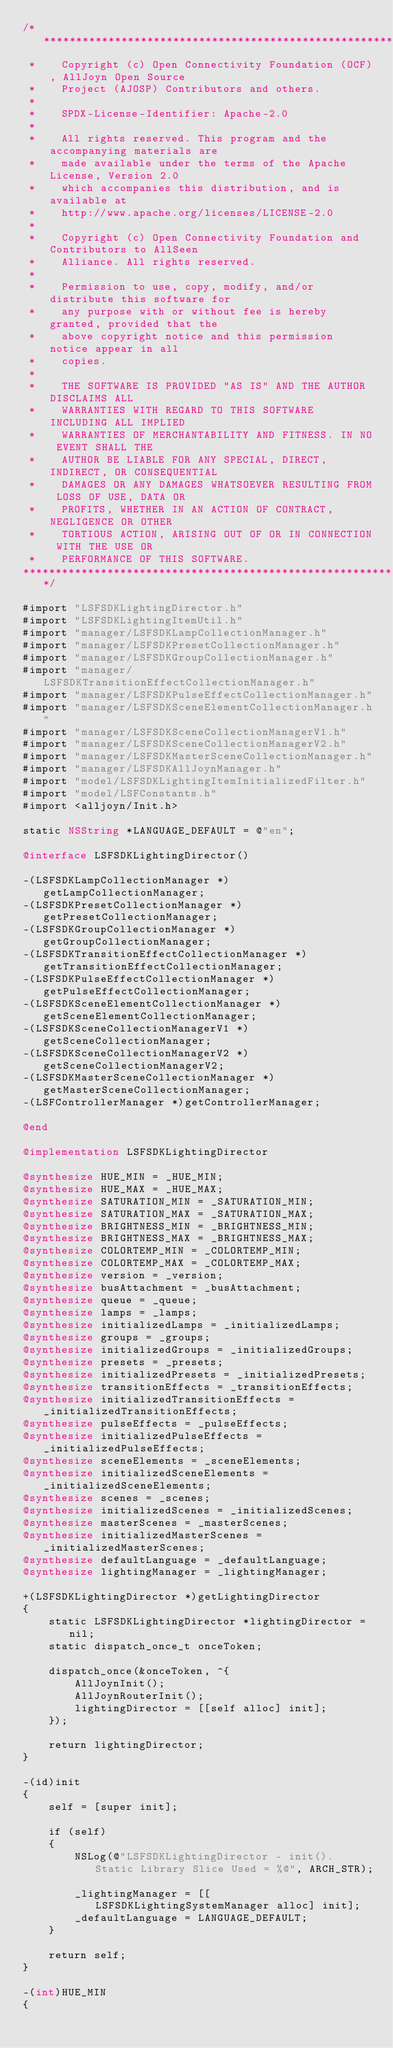Convert code to text. <code><loc_0><loc_0><loc_500><loc_500><_ObjectiveC_>/******************************************************************************
 *    Copyright (c) Open Connectivity Foundation (OCF), AllJoyn Open Source
 *    Project (AJOSP) Contributors and others.
 *    
 *    SPDX-License-Identifier: Apache-2.0
 *    
 *    All rights reserved. This program and the accompanying materials are
 *    made available under the terms of the Apache License, Version 2.0
 *    which accompanies this distribution, and is available at
 *    http://www.apache.org/licenses/LICENSE-2.0
 *    
 *    Copyright (c) Open Connectivity Foundation and Contributors to AllSeen
 *    Alliance. All rights reserved.
 *    
 *    Permission to use, copy, modify, and/or distribute this software for
 *    any purpose with or without fee is hereby granted, provided that the
 *    above copyright notice and this permission notice appear in all
 *    copies.
 *    
 *    THE SOFTWARE IS PROVIDED "AS IS" AND THE AUTHOR DISCLAIMS ALL
 *    WARRANTIES WITH REGARD TO THIS SOFTWARE INCLUDING ALL IMPLIED
 *    WARRANTIES OF MERCHANTABILITY AND FITNESS. IN NO EVENT SHALL THE
 *    AUTHOR BE LIABLE FOR ANY SPECIAL, DIRECT, INDIRECT, OR CONSEQUENTIAL
 *    DAMAGES OR ANY DAMAGES WHATSOEVER RESULTING FROM LOSS OF USE, DATA OR
 *    PROFITS, WHETHER IN AN ACTION OF CONTRACT, NEGLIGENCE OR OTHER
 *    TORTIOUS ACTION, ARISING OUT OF OR IN CONNECTION WITH THE USE OR
 *    PERFORMANCE OF THIS SOFTWARE.
******************************************************************************/

#import "LSFSDKLightingDirector.h"
#import "LSFSDKLightingItemUtil.h"
#import "manager/LSFSDKLampCollectionManager.h"
#import "manager/LSFSDKPresetCollectionManager.h"
#import "manager/LSFSDKGroupCollectionManager.h"
#import "manager/LSFSDKTransitionEffectCollectionManager.h"
#import "manager/LSFSDKPulseEffectCollectionManager.h"
#import "manager/LSFSDKSceneElementCollectionManager.h"
#import "manager/LSFSDKSceneCollectionManagerV1.h"
#import "manager/LSFSDKSceneCollectionManagerV2.h"
#import "manager/LSFSDKMasterSceneCollectionManager.h"
#import "manager/LSFSDKAllJoynManager.h"
#import "model/LSFSDKLightingItemInitializedFilter.h"
#import "model/LSFConstants.h"
#import <alljoyn/Init.h>

static NSString *LANGUAGE_DEFAULT = @"en";

@interface LSFSDKLightingDirector()

-(LSFSDKLampCollectionManager *)getLampCollectionManager;
-(LSFSDKPresetCollectionManager *)getPresetCollectionManager;
-(LSFSDKGroupCollectionManager *)getGroupCollectionManager;
-(LSFSDKTransitionEffectCollectionManager *)getTransitionEffectCollectionManager;
-(LSFSDKPulseEffectCollectionManager *)getPulseEffectCollectionManager;
-(LSFSDKSceneElementCollectionManager *)getSceneElementCollectionManager;
-(LSFSDKSceneCollectionManagerV1 *)getSceneCollectionManager;
-(LSFSDKSceneCollectionManagerV2 *)getSceneCollectionManagerV2;
-(LSFSDKMasterSceneCollectionManager *)getMasterSceneCollectionManager;
-(LSFControllerManager *)getControllerManager;

@end

@implementation LSFSDKLightingDirector

@synthesize HUE_MIN = _HUE_MIN;
@synthesize HUE_MAX = _HUE_MAX;
@synthesize SATURATION_MIN = _SATURATION_MIN;
@synthesize SATURATION_MAX = _SATURATION_MAX;
@synthesize BRIGHTNESS_MIN = _BRIGHTNESS_MIN;
@synthesize BRIGHTNESS_MAX = _BRIGHTNESS_MAX;
@synthesize COLORTEMP_MIN = _COLORTEMP_MIN;
@synthesize COLORTEMP_MAX = _COLORTEMP_MAX;
@synthesize version = _version;
@synthesize busAttachment = _busAttachment;
@synthesize queue = _queue;
@synthesize lamps = _lamps;
@synthesize initializedLamps = _initializedLamps;
@synthesize groups = _groups;
@synthesize initializedGroups = _initializedGroups;
@synthesize presets = _presets;
@synthesize initializedPresets = _initializedPresets;
@synthesize transitionEffects = _transitionEffects;
@synthesize initializedTransitionEffects = _initializedTransitionEffects;
@synthesize pulseEffects = _pulseEffects;
@synthesize initializedPulseEffects = _initializedPulseEffects;
@synthesize sceneElements = _sceneElements;
@synthesize initializedSceneElements = _initializedSceneElements;
@synthesize scenes = _scenes;
@synthesize initializedScenes = _initializedScenes;
@synthesize masterScenes = _masterScenes;
@synthesize initializedMasterScenes = _initializedMasterScenes;
@synthesize defaultLanguage = _defaultLanguage;
@synthesize lightingManager = _lightingManager;

+(LSFSDKLightingDirector *)getLightingDirector
{
    static LSFSDKLightingDirector *lightingDirector = nil;
    static dispatch_once_t onceToken;

    dispatch_once(&onceToken, ^{
        AllJoynInit();
        AllJoynRouterInit();
        lightingDirector = [[self alloc] init];
    });

    return lightingDirector;
}

-(id)init
{
    self = [super init];

    if (self)
    {
        NSLog(@"LSFSDKLightingDirector - init(). Static Library Slice Used = %@", ARCH_STR);

        _lightingManager = [[LSFSDKLightingSystemManager alloc] init];
        _defaultLanguage = LANGUAGE_DEFAULT;
    }

    return self;
}

-(int)HUE_MIN
{</code> 